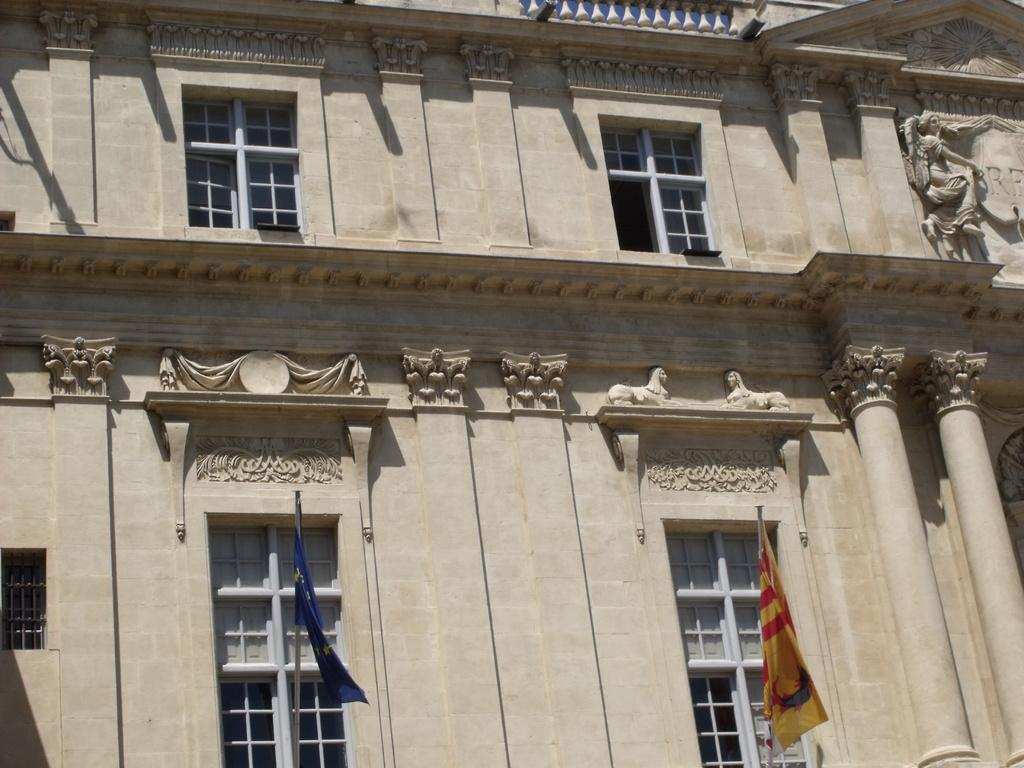What is the main subject in the center of the image? There is a building in the center of the image. What feature can be seen on the building? The building has windows. What else is present at the bottom side of the image? There are flags at the bottom side of the image. How many ants can be seen crawling on the building in the image? There are no ants present in the image. What is the interest rate for the building in the image? The image does not provide information about interest rates for the building. 